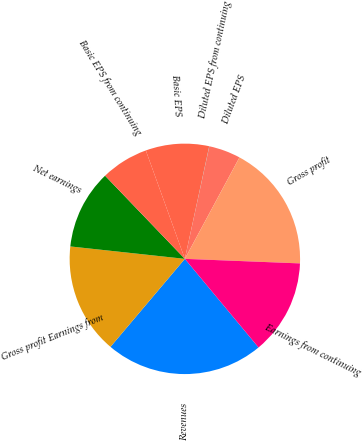<chart> <loc_0><loc_0><loc_500><loc_500><pie_chart><fcel>Revenues<fcel>Gross profit Earnings from<fcel>Net earnings<fcel>Basic EPS from continuing<fcel>Basic EPS<fcel>Diluted EPS from continuing<fcel>Diluted EPS<fcel>Gross profit<fcel>Earnings from continuing<nl><fcel>22.21%<fcel>15.55%<fcel>11.11%<fcel>6.67%<fcel>8.89%<fcel>0.02%<fcel>4.45%<fcel>17.77%<fcel>13.33%<nl></chart> 